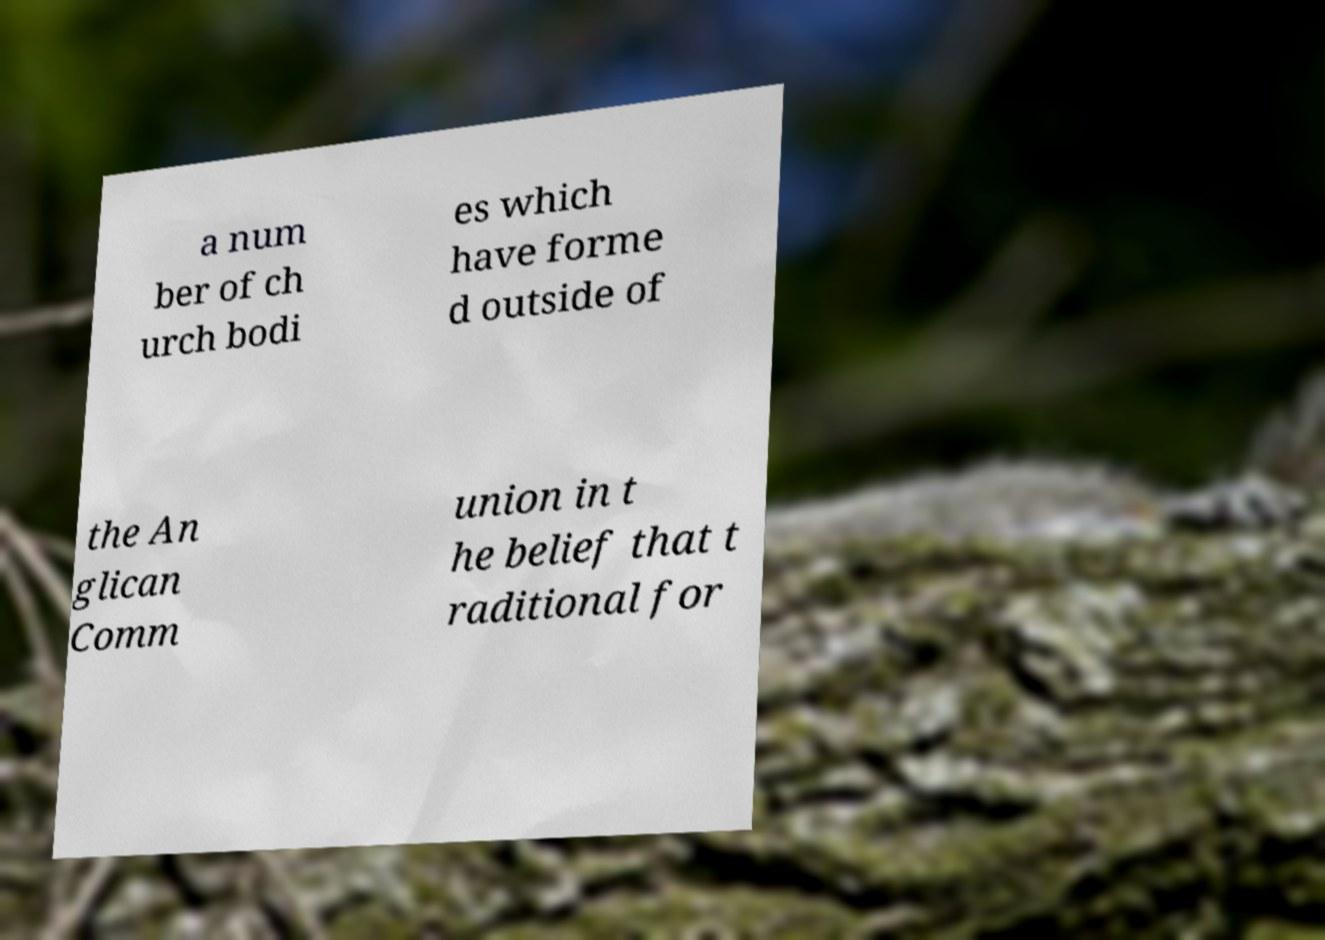Could you assist in decoding the text presented in this image and type it out clearly? a num ber of ch urch bodi es which have forme d outside of the An glican Comm union in t he belief that t raditional for 